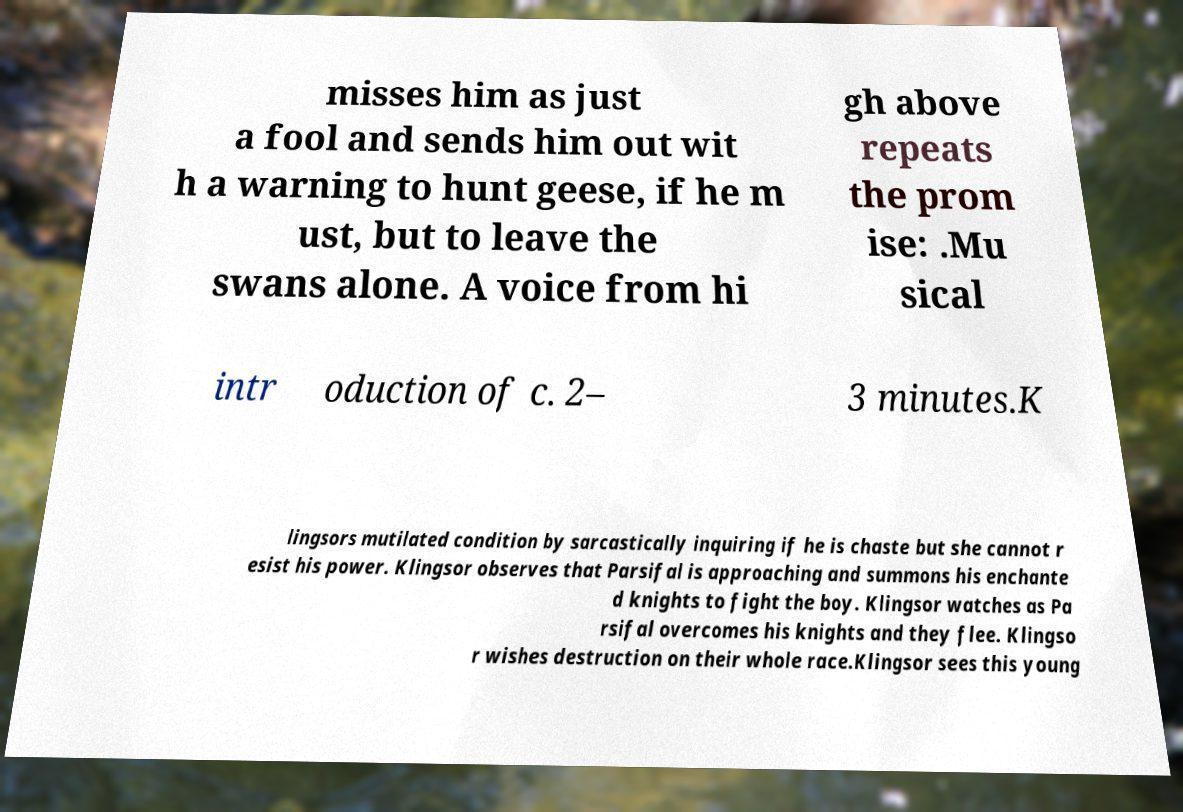Can you read and provide the text displayed in the image?This photo seems to have some interesting text. Can you extract and type it out for me? misses him as just a fool and sends him out wit h a warning to hunt geese, if he m ust, but to leave the swans alone. A voice from hi gh above repeats the prom ise: .Mu sical intr oduction of c. 2– 3 minutes.K lingsors mutilated condition by sarcastically inquiring if he is chaste but she cannot r esist his power. Klingsor observes that Parsifal is approaching and summons his enchante d knights to fight the boy. Klingsor watches as Pa rsifal overcomes his knights and they flee. Klingso r wishes destruction on their whole race.Klingsor sees this young 